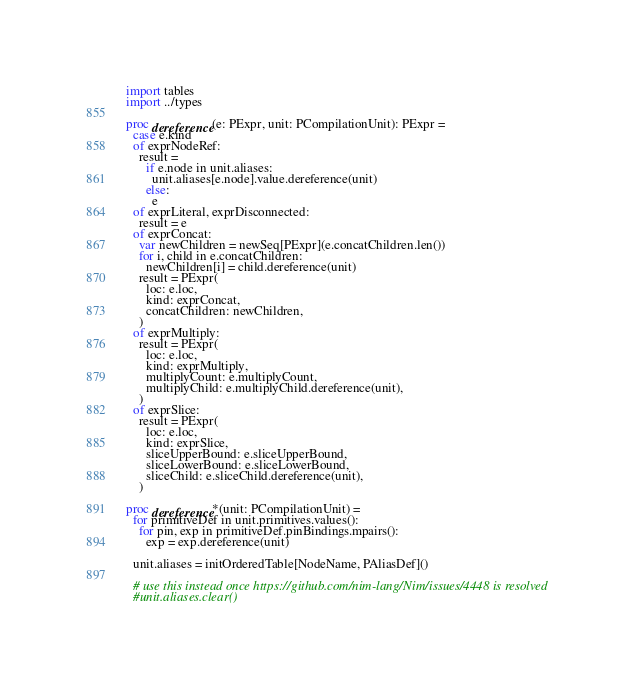Convert code to text. <code><loc_0><loc_0><loc_500><loc_500><_Nim_>import tables
import ../types

proc dereference(e: PExpr, unit: PCompilationUnit): PExpr =
  case e.kind
  of exprNodeRef:
    result =
      if e.node in unit.aliases:
        unit.aliases[e.node].value.dereference(unit)
      else:
        e
  of exprLiteral, exprDisconnected:
    result = e
  of exprConcat:
    var newChildren = newSeq[PExpr](e.concatChildren.len())
    for i, child in e.concatChildren:
      newChildren[i] = child.dereference(unit)
    result = PExpr(
      loc: e.loc,
      kind: exprConcat,
      concatChildren: newChildren,
    )
  of exprMultiply:
    result = PExpr(
      loc: e.loc,
      kind: exprMultiply,
      multiplyCount: e.multiplyCount,
      multiplyChild: e.multiplyChild.dereference(unit),
    )
  of exprSlice:
    result = PExpr(
      loc: e.loc,
      kind: exprSlice,
      sliceUpperBound: e.sliceUpperBound,
      sliceLowerBound: e.sliceLowerBound,
      sliceChild: e.sliceChild.dereference(unit),
    )

proc dereference*(unit: PCompilationUnit) =
  for primitiveDef in unit.primitives.values():
    for pin, exp in primitiveDef.pinBindings.mpairs():
      exp = exp.dereference(unit)

  unit.aliases = initOrderedTable[NodeName, PAliasDef]()

  # use this instead once https://github.com/nim-lang/Nim/issues/4448 is resolved
  #unit.aliases.clear()
</code> 